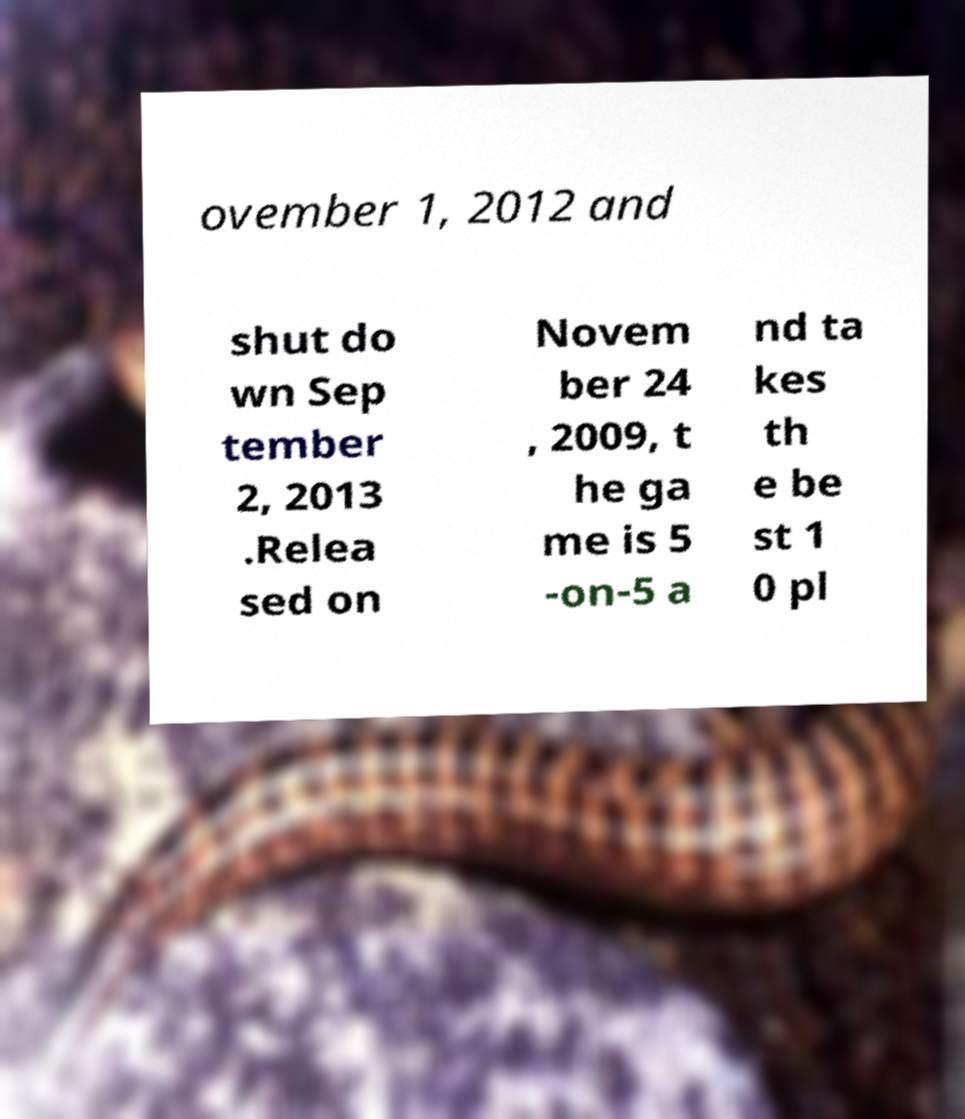I need the written content from this picture converted into text. Can you do that? ovember 1, 2012 and shut do wn Sep tember 2, 2013 .Relea sed on Novem ber 24 , 2009, t he ga me is 5 -on-5 a nd ta kes th e be st 1 0 pl 